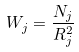<formula> <loc_0><loc_0><loc_500><loc_500>W _ { j } = \frac { N _ { j } } { R _ { j } ^ { 2 } }</formula> 